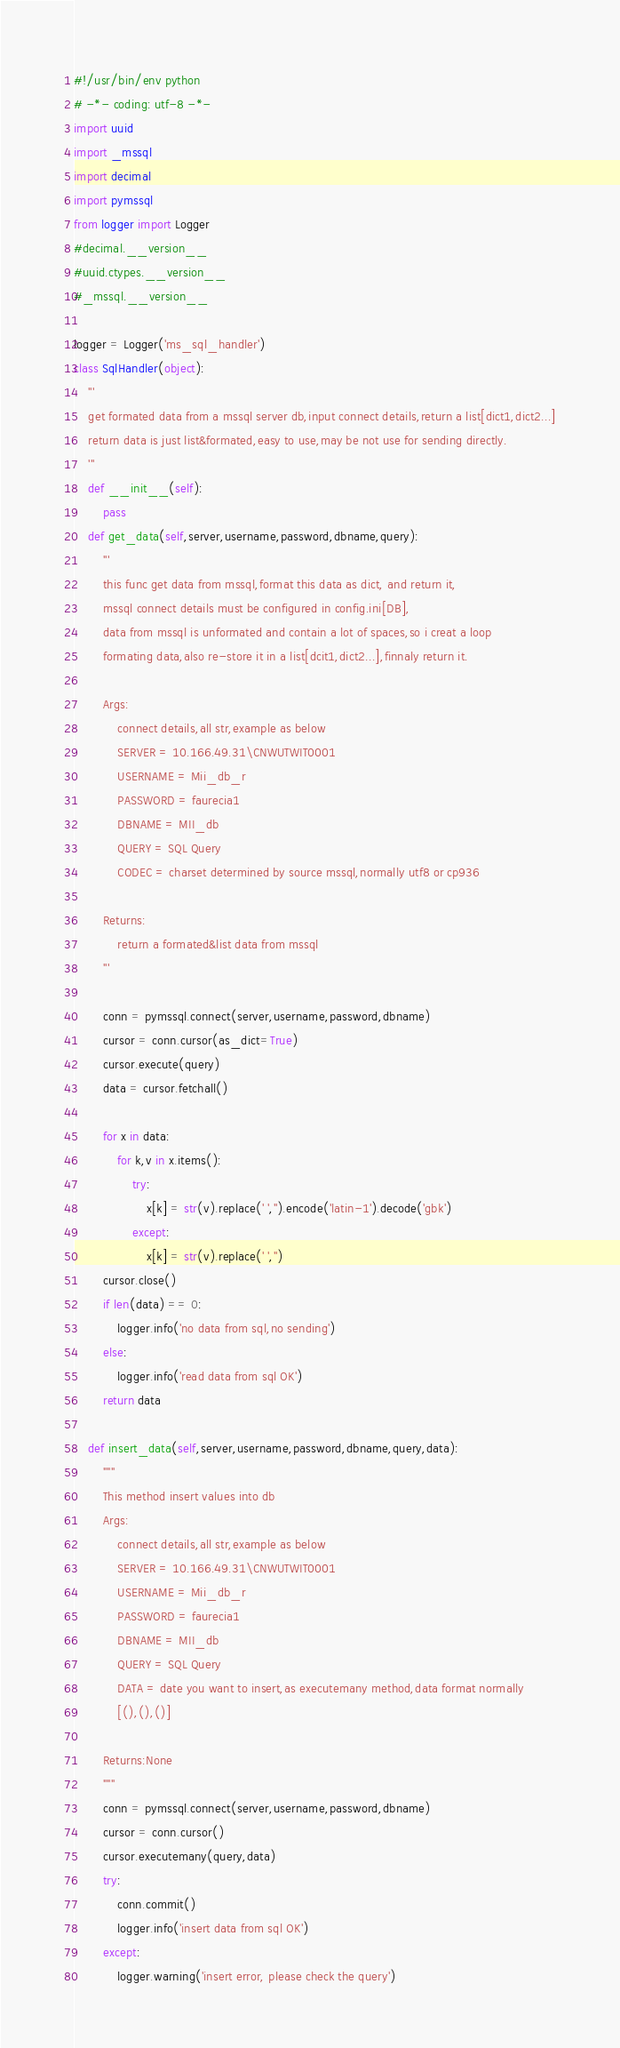Convert code to text. <code><loc_0><loc_0><loc_500><loc_500><_Python_>#!/usr/bin/env python
# -*- coding: utf-8 -*- 
import uuid
import _mssql
import decimal
import pymssql
from logger import Logger
#decimal.__version__
#uuid.ctypes.__version__
#_mssql.__version__

logger = Logger('ms_sql_handler')
class SqlHandler(object):
    '''
    get formated data from a mssql server db,input connect details,return a list[dict1,dict2...]
    return data is just list&formated,easy to use,may be not use for sending directly.
    '''
    def __init__(self):
        pass
    def get_data(self,server,username,password,dbname,query):
        '''
        this func get data from mssql,format this data as dict, and return it,
        mssql connect details must be configured in config.ini[DB],
        data from mssql is unformated and contain a lot of spaces,so i creat a loop
        formating data,also re-store it in a list[dcit1,dict2...],finnaly return it.

        Args:
            connect details,all str,example as below
            SERVER = 10.166.49.31\CNWUTWIT0001
            USERNAME = Mii_db_r
            PASSWORD = faurecia1
            DBNAME = MII_db
            QUERY = SQL Query
            CODEC = charset determined by source mssql,normally utf8 or cp936

        Returns:
            return a formated&list data from mssql
        ''' 

        conn = pymssql.connect(server,username,password,dbname)
        cursor = conn.cursor(as_dict=True)
        cursor.execute(query)
        data = cursor.fetchall()

        for x in data:
            for k,v in x.items():
                try:
                    x[k] = str(v).replace(' ','').encode('latin-1').decode('gbk')
                except:
                    x[k] = str(v).replace(' ','')
        cursor.close()
        if len(data) == 0:
            logger.info('no data from sql,no sending')
        else:
            logger.info('read data from sql OK')
        return data

    def insert_data(self,server,username,password,dbname,query,data):
        """
        This method insert values into db
        Args:
            connect details,all str,example as below
            SERVER = 10.166.49.31\CNWUTWIT0001
            USERNAME = Mii_db_r
            PASSWORD = faurecia1
            DBNAME = MII_db
            QUERY = SQL Query
            DATA = date you want to insert,as executemany method,data format normally
            [(),(),()]

        Returns:None
        """
        conn = pymssql.connect(server,username,password,dbname)
        cursor = conn.cursor()
        cursor.executemany(query,data)
        try:
            conn.commit()
            logger.info('insert data from sql OK')
        except:
            logger.warning('insert error, please check the query')
</code> 